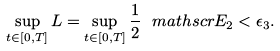<formula> <loc_0><loc_0><loc_500><loc_500>\sup _ { t \in [ 0 , T ] } L = \sup _ { t \in [ 0 , T ] } \frac { 1 } { 2 } \ m a t h s c r { E } _ { 2 } < \epsilon _ { 3 } .</formula> 